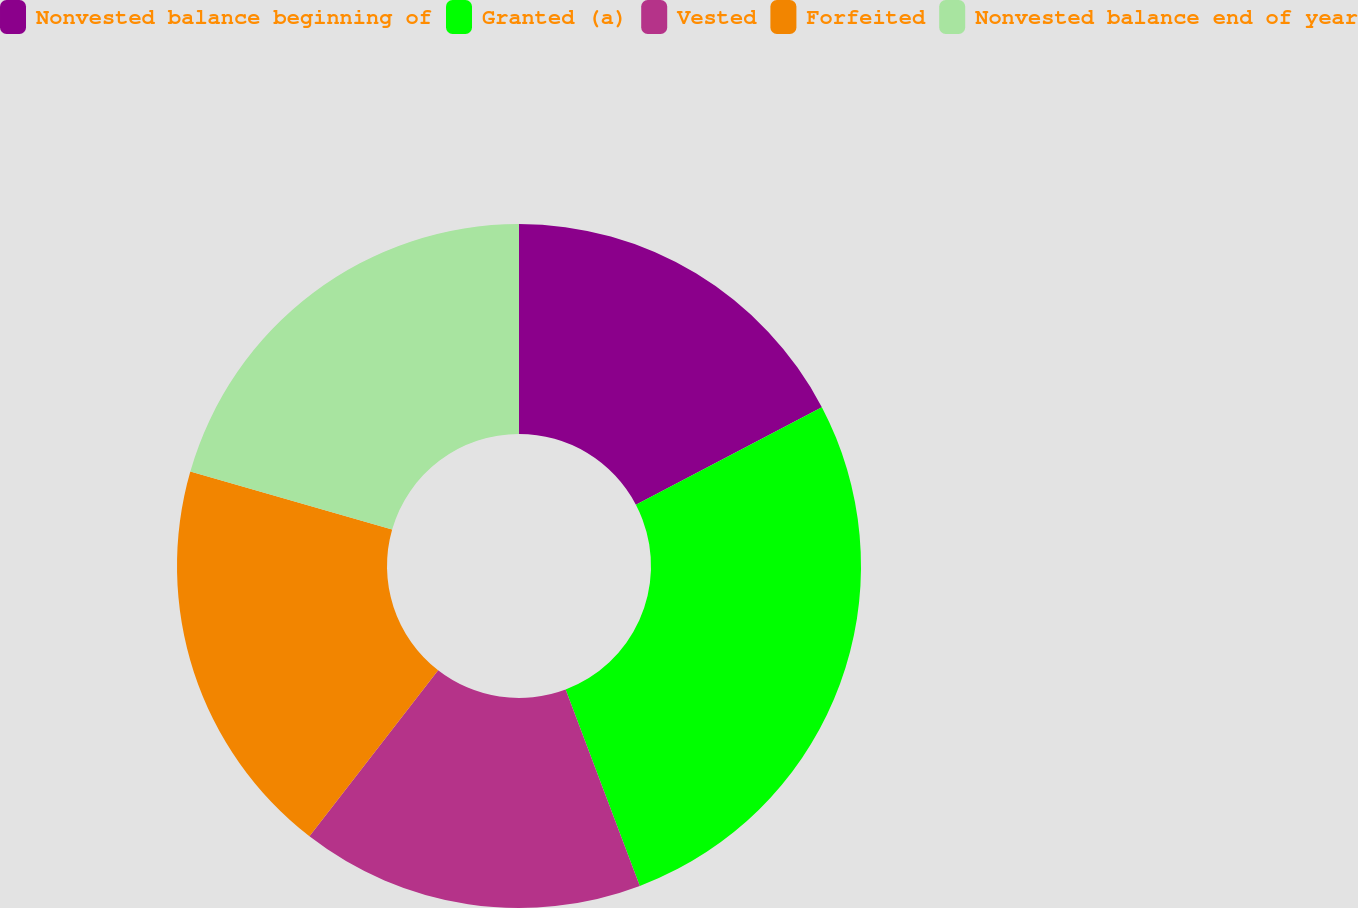<chart> <loc_0><loc_0><loc_500><loc_500><pie_chart><fcel>Nonvested balance beginning of<fcel>Granted (a)<fcel>Vested<fcel>Forfeited<fcel>Nonvested balance end of year<nl><fcel>17.31%<fcel>26.94%<fcel>16.24%<fcel>18.96%<fcel>20.54%<nl></chart> 